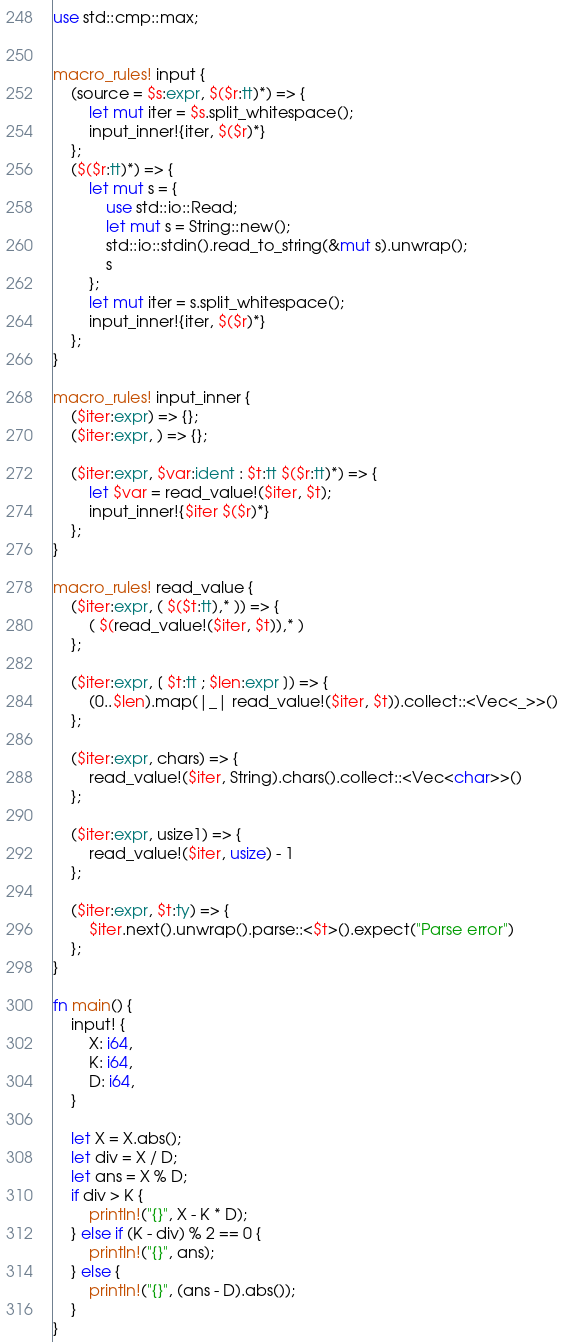<code> <loc_0><loc_0><loc_500><loc_500><_Rust_>use std::cmp::max;


macro_rules! input {
    (source = $s:expr, $($r:tt)*) => {
        let mut iter = $s.split_whitespace();
        input_inner!{iter, $($r)*}
    };
    ($($r:tt)*) => {
        let mut s = {
            use std::io::Read;
            let mut s = String::new();
            std::io::stdin().read_to_string(&mut s).unwrap();
            s
        };
        let mut iter = s.split_whitespace();
        input_inner!{iter, $($r)*}
    };
}

macro_rules! input_inner {
    ($iter:expr) => {};
    ($iter:expr, ) => {};

    ($iter:expr, $var:ident : $t:tt $($r:tt)*) => {
        let $var = read_value!($iter, $t);
        input_inner!{$iter $($r)*}
    };
}

macro_rules! read_value {
    ($iter:expr, ( $($t:tt),* )) => {
        ( $(read_value!($iter, $t)),* )
    };

    ($iter:expr, [ $t:tt ; $len:expr ]) => {
        (0..$len).map(|_| read_value!($iter, $t)).collect::<Vec<_>>()
    };

    ($iter:expr, chars) => {
        read_value!($iter, String).chars().collect::<Vec<char>>()
    };

    ($iter:expr, usize1) => {
        read_value!($iter, usize) - 1
    };

    ($iter:expr, $t:ty) => {
        $iter.next().unwrap().parse::<$t>().expect("Parse error")
    };
}

fn main() {
    input! {
        X: i64,
        K: i64,
        D: i64,
    }

    let X = X.abs();
    let div = X / D;
    let ans = X % D;
    if div > K {
        println!("{}", X - K * D);
    } else if (K - div) % 2 == 0 {
        println!("{}", ans);
    } else {
        println!("{}", (ans - D).abs());
    }
}
</code> 